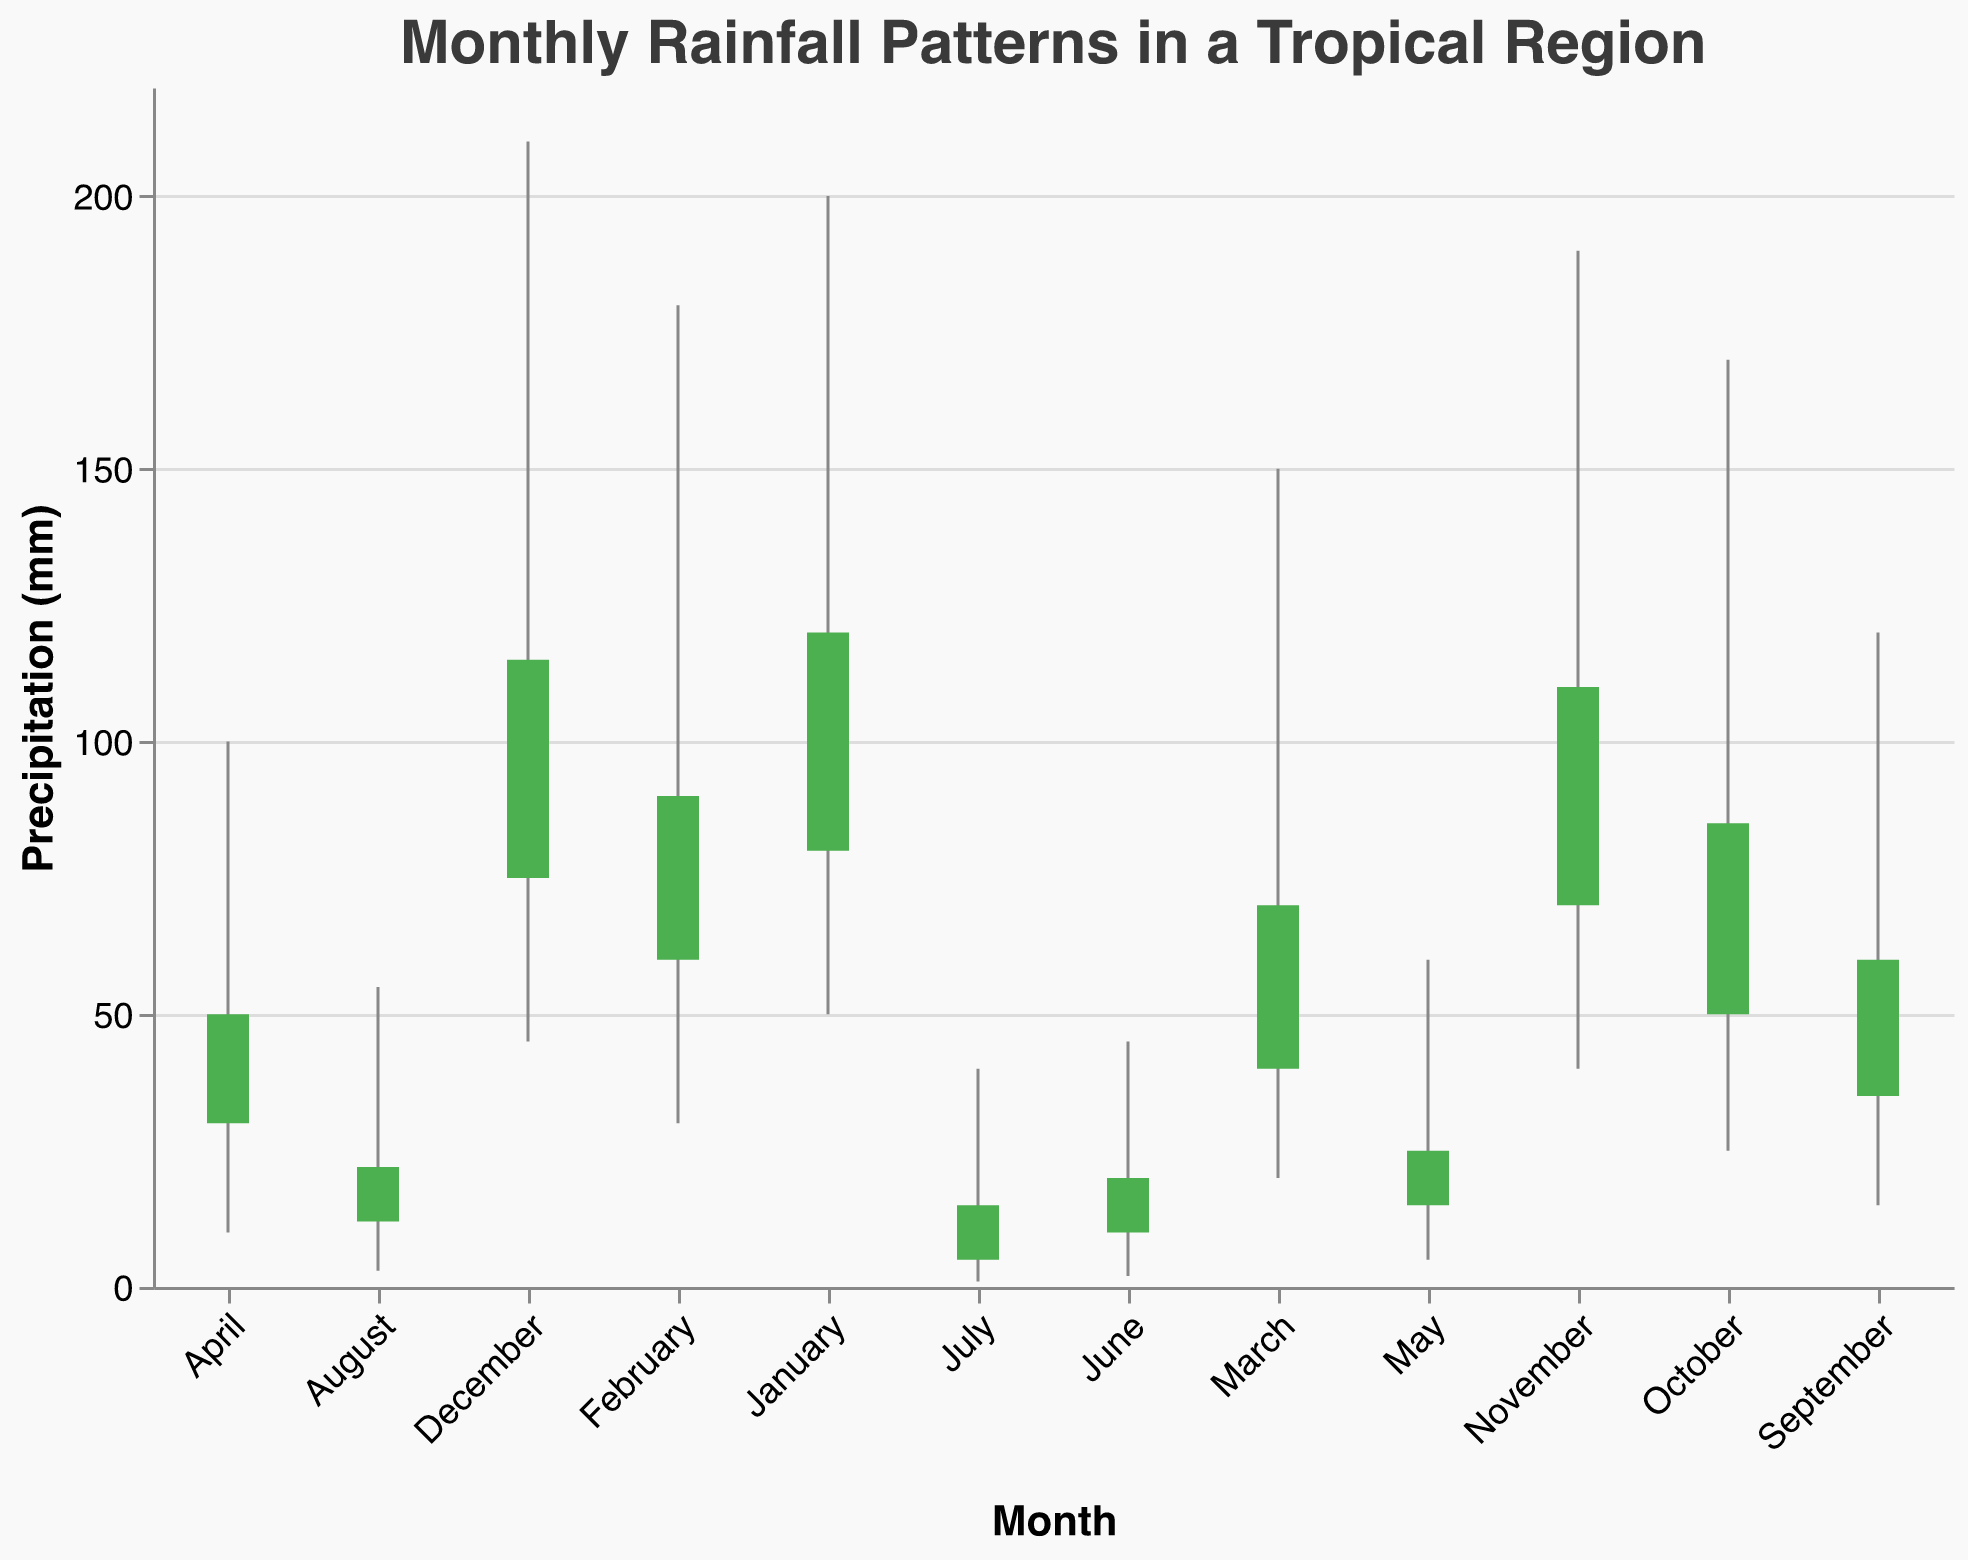What's the maximum rainfall in December? Look at the vertical line and bar for December, and identify the top value.
Answer: 210 mm Which month has the lowest average precipitation? Compare the "Avg" values for all months and find the smallest one.
Answer: July What is the range of precipitation in November? Subtract the minimum value from the maximum value in November (Max - Min).
Answer: 150 mm In which month did the rainfall increase the most from the opening to the closing value? Identify the month with the largest difference between the "Close" and "Open" values.
Answer: January Which months have an increase in rainfall from the opening to the closing value? Check the months where the "Close" value is greater than the "Open" value.
Answer: January, February, March, April, August, September, October, November, December What is the total precipitation for April and May combined? Sum the "Close" values of April and May (50 + 25).
Answer: 75 mm What is the average maximum precipitation across all months? Calculate the average of the "Max" values (200 + 180 + 150 + 100 + 60 + 45 + 40 + 55 + 120 + 170 + 190 + 210) / 12.
Answer: 128.75 mm How does February's average precipitation compare to November's? Compare the "Avg" values for February and November (90 vs. 102.5).
Answer: February has less Which month has the largest minimum precipitation? Find the "Min" value that is the largest among all months.
Answer: January What is the median closing value of the year? List the "Close" values, sort them, and find the median value.
Answer: 77.5 (Midpoint between 70 and 85 since there are 12 months) 